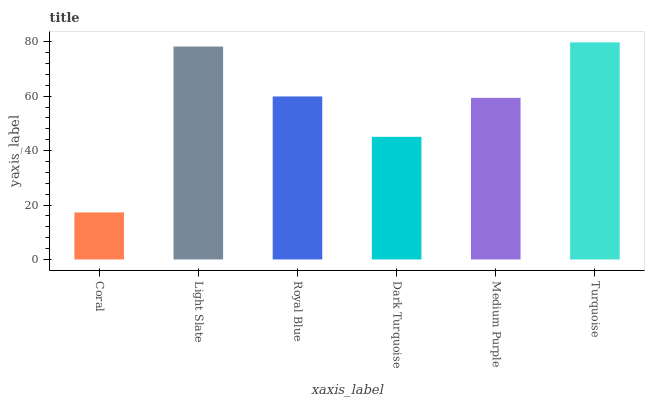Is Coral the minimum?
Answer yes or no. Yes. Is Turquoise the maximum?
Answer yes or no. Yes. Is Light Slate the minimum?
Answer yes or no. No. Is Light Slate the maximum?
Answer yes or no. No. Is Light Slate greater than Coral?
Answer yes or no. Yes. Is Coral less than Light Slate?
Answer yes or no. Yes. Is Coral greater than Light Slate?
Answer yes or no. No. Is Light Slate less than Coral?
Answer yes or no. No. Is Royal Blue the high median?
Answer yes or no. Yes. Is Medium Purple the low median?
Answer yes or no. Yes. Is Dark Turquoise the high median?
Answer yes or no. No. Is Dark Turquoise the low median?
Answer yes or no. No. 